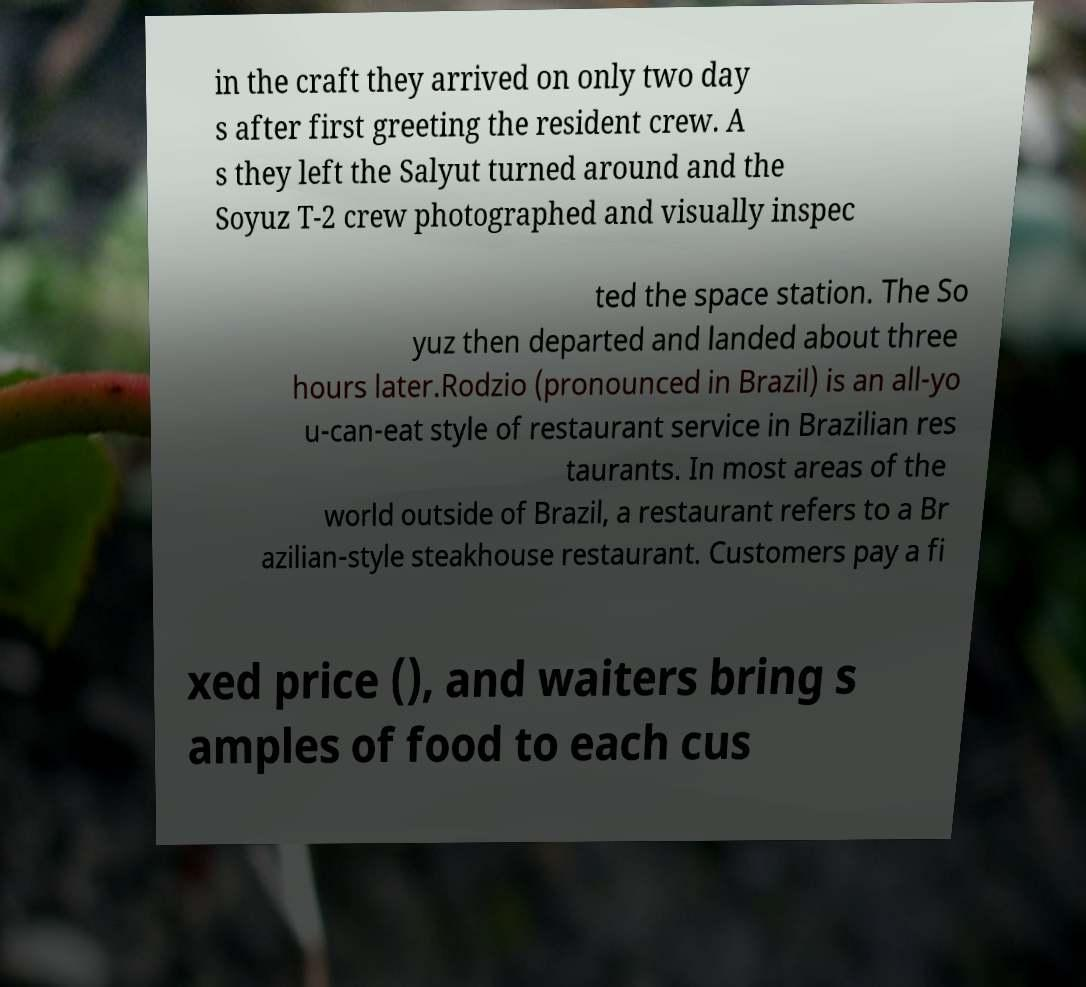For documentation purposes, I need the text within this image transcribed. Could you provide that? in the craft they arrived on only two day s after first greeting the resident crew. A s they left the Salyut turned around and the Soyuz T-2 crew photographed and visually inspec ted the space station. The So yuz then departed and landed about three hours later.Rodzio (pronounced in Brazil) is an all-yo u-can-eat style of restaurant service in Brazilian res taurants. In most areas of the world outside of Brazil, a restaurant refers to a Br azilian-style steakhouse restaurant. Customers pay a fi xed price (), and waiters bring s amples of food to each cus 